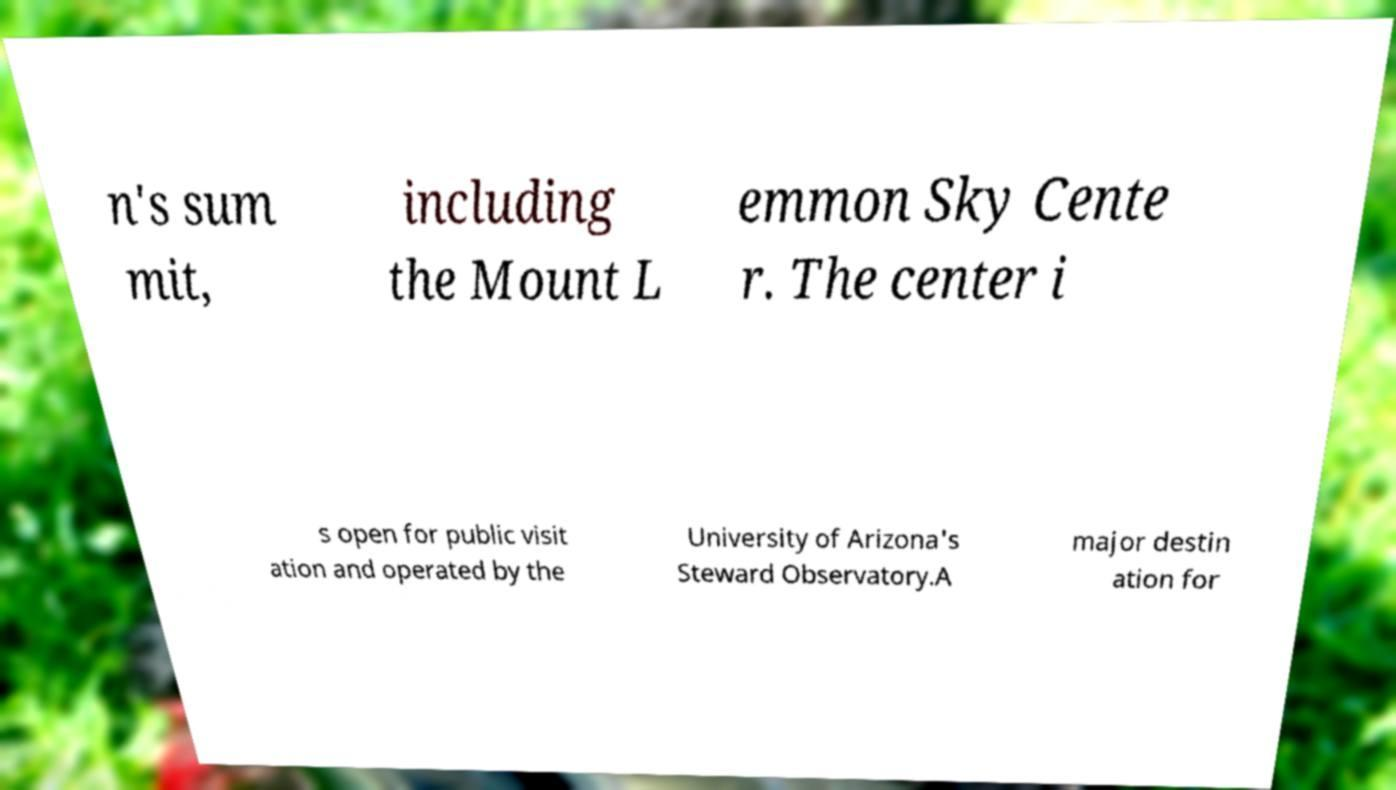What messages or text are displayed in this image? I need them in a readable, typed format. n's sum mit, including the Mount L emmon Sky Cente r. The center i s open for public visit ation and operated by the University of Arizona's Steward Observatory.A major destin ation for 